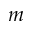Convert formula to latex. <formula><loc_0><loc_0><loc_500><loc_500>m</formula> 